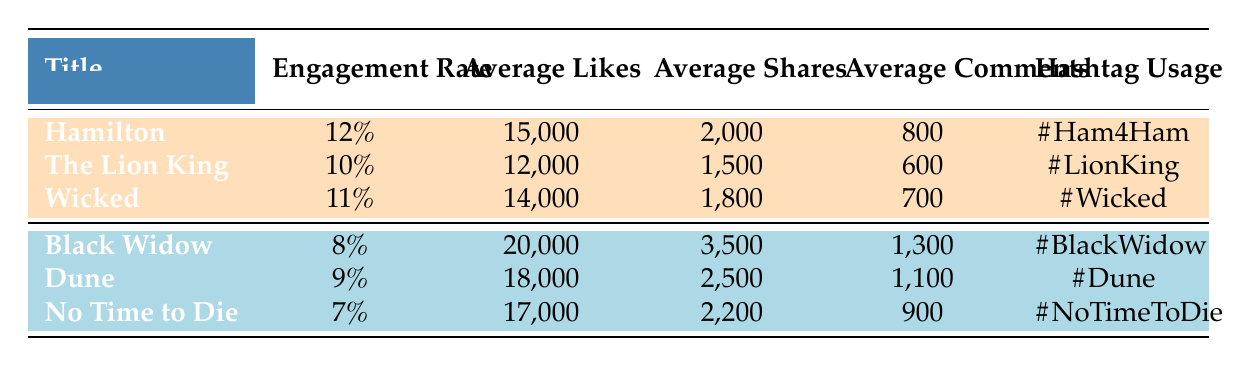What is the engagement rate for 'Wicked'? The table lists the engagement rates per show. For 'Wicked', the engagement rate is shown as 11%.
Answer: 11% Which theater show had the highest average likes? By looking at the 'Average Likes' column, 'Black Widow' has the highest average likes, but since it is a film, we focus on theater shows only. 'Hamilton' has the highest average likes at 15,000.
Answer: 15,000 How many more average shares did 'Black Widow' have compared to 'The Lion King'? 'Black Widow' has 3,500 average shares, while 'The Lion King' has 1,500. Subtracting these gives 3,500 - 1,500 = 2,000 additional shares for 'Black Widow'.
Answer: 2,000 Is the engagement rate for 'The Lion King' higher than that for 'No Time to Die'? 'The Lion King' has an engagement rate of 10%, while 'No Time to Die' has an engagement rate of 7%. Since 10% is greater than 7%, the answer is yes.
Answer: Yes What is the average number of likes for all theater shows combined? The average likes can be found by summing the average likes of all theater shows: 15,000 (Hamilton) + 12,000 (The Lion King) + 14,000 (Wicked) = 41,000. There are 3 shows, so the average is 41,000 / 3 = 13,666.67.
Answer: 13,666.67 Which show has the lowest average comments? By examining the 'Average Comments' column, 'The Lion King' has 600 comments, which is the lowest compared to 'Hamilton' and 'Wicked'.
Answer: 600 What is the total average likes for all film releases? Adding the average likes for the film releases: 20,000 (Black Widow) + 18,000 (Dune) + 17,000 (No Time to Die) = 55,000.
Answer: 55,000 Is the hashtag for 'Hamilton' used more than once for other shows? The hashtag for 'Hamilton' is #Ham4Ham, which is unique to that show. The other shows have different hashtags. Since #Ham4Ham does not appear elsewhere, the answer is no.
Answer: No 